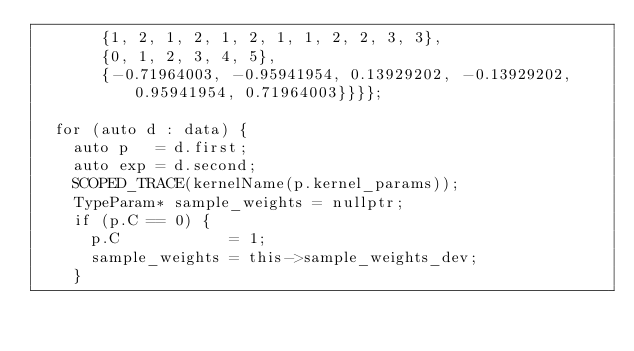<code> <loc_0><loc_0><loc_500><loc_500><_Cuda_>       {1, 2, 1, 2, 1, 2, 1, 1, 2, 2, 3, 3},
       {0, 1, 2, 3, 4, 5},
       {-0.71964003, -0.95941954, 0.13929202, -0.13929202, 0.95941954, 0.71964003}}}};

  for (auto d : data) {
    auto p   = d.first;
    auto exp = d.second;
    SCOPED_TRACE(kernelName(p.kernel_params));
    TypeParam* sample_weights = nullptr;
    if (p.C == 0) {
      p.C            = 1;
      sample_weights = this->sample_weights_dev;
    }</code> 